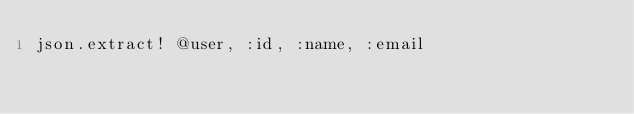Convert code to text. <code><loc_0><loc_0><loc_500><loc_500><_Ruby_>json.extract! @user, :id, :name, :email</code> 